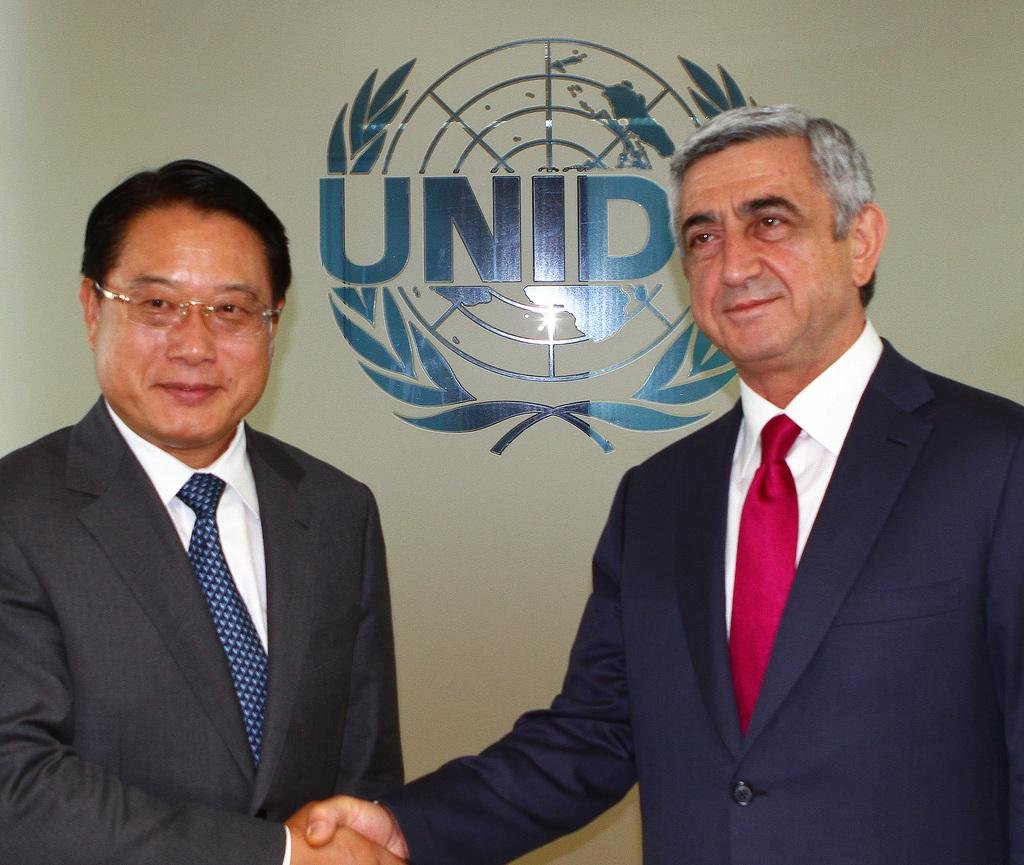How many people are in the image? There are two persons in the image. What are the persons doing in the image? The persons are standing and smiling. What can be seen in the background of the image? There is a wall in the background of the image. Where is the nest located in the image? There is no nest present in the image. What grade are the persons in the image? The provided facts do not mention any information about the persons' grades. 